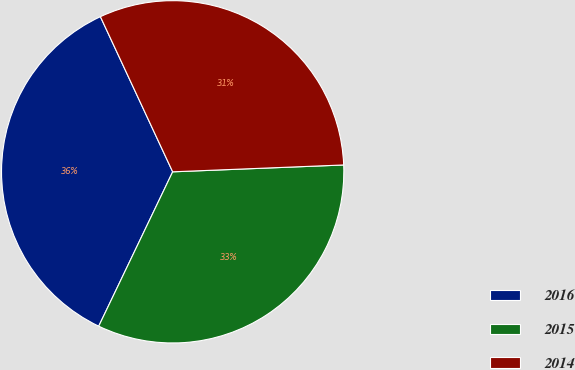Convert chart to OTSL. <chart><loc_0><loc_0><loc_500><loc_500><pie_chart><fcel>2016<fcel>2015<fcel>2014<nl><fcel>35.95%<fcel>32.75%<fcel>31.3%<nl></chart> 